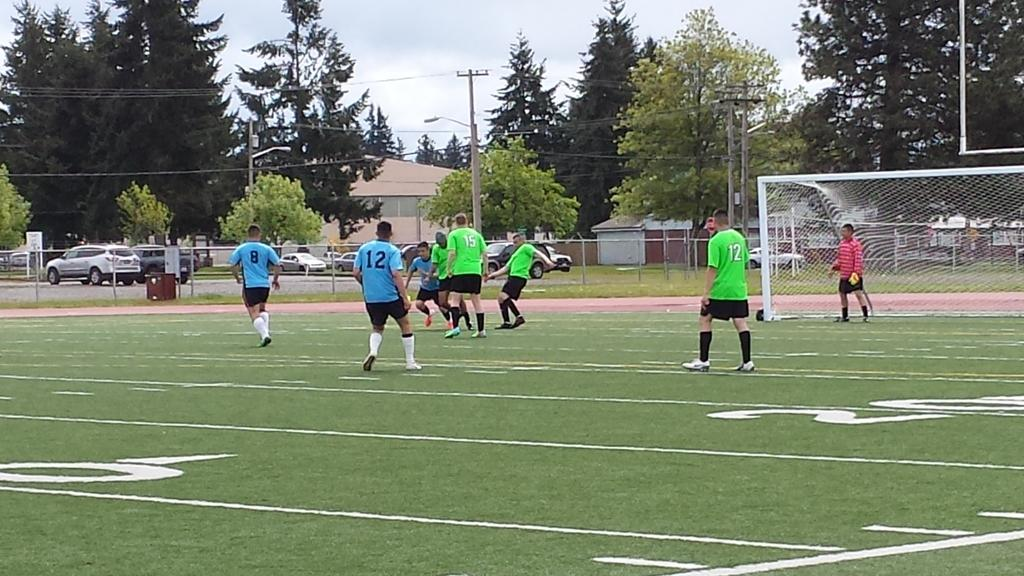<image>
Provide a brief description of the given image. Player number 12 in green looks on during a competitive soccer game. 